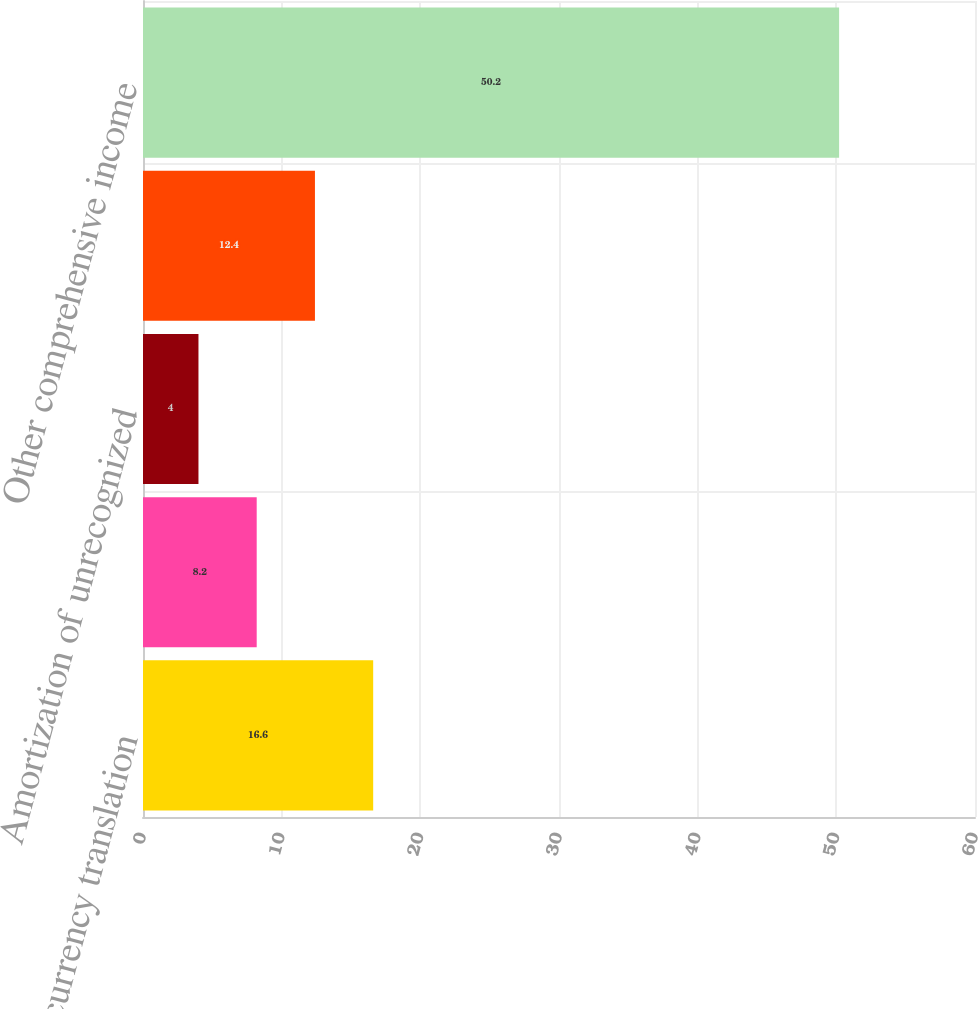Convert chart to OTSL. <chart><loc_0><loc_0><loc_500><loc_500><bar_chart><fcel>Foreign currency translation<fcel>Net actuarial (loss) gain<fcel>Amortization of unrecognized<fcel>(Loss) gain on forward<fcel>Other comprehensive income<nl><fcel>16.6<fcel>8.2<fcel>4<fcel>12.4<fcel>50.2<nl></chart> 